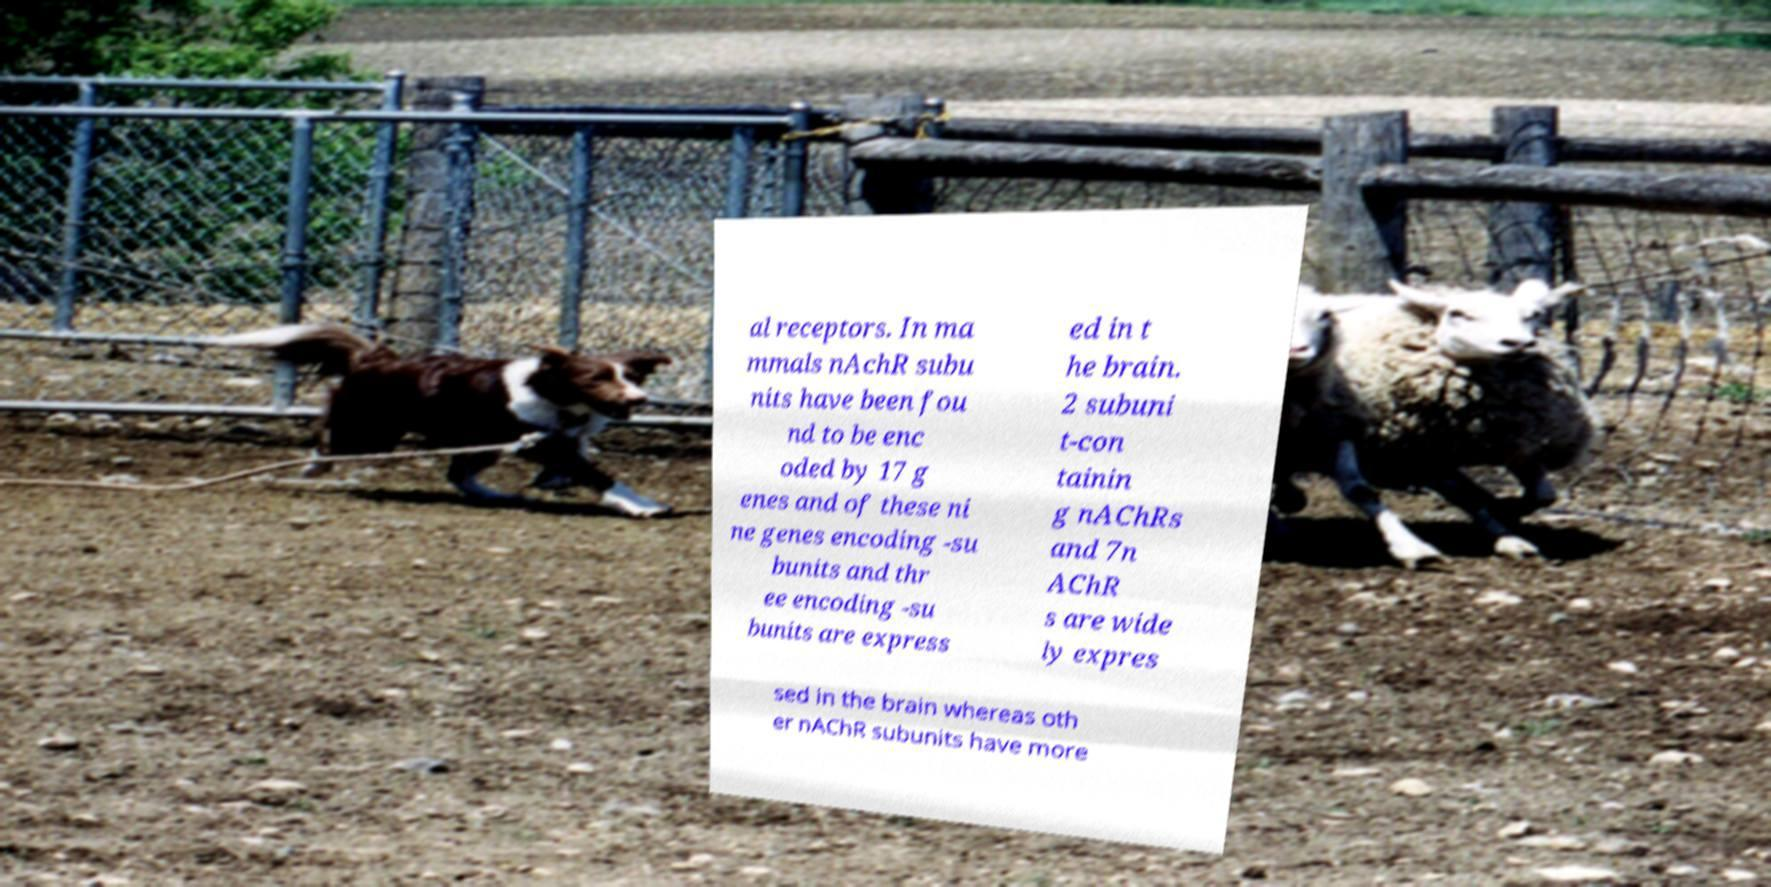Please read and relay the text visible in this image. What does it say? al receptors. In ma mmals nAchR subu nits have been fou nd to be enc oded by 17 g enes and of these ni ne genes encoding -su bunits and thr ee encoding -su bunits are express ed in t he brain. 2 subuni t-con tainin g nAChRs and 7n AChR s are wide ly expres sed in the brain whereas oth er nAChR subunits have more 